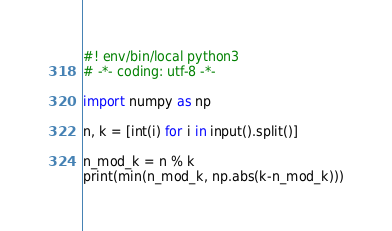Convert code to text. <code><loc_0><loc_0><loc_500><loc_500><_Python_>#! env/bin/local python3
# -*- coding: utf-8 -*-

import numpy as np

n, k = [int(i) for i in input().split()]

n_mod_k = n % k 
print(min(n_mod_k, np.abs(k-n_mod_k)))</code> 